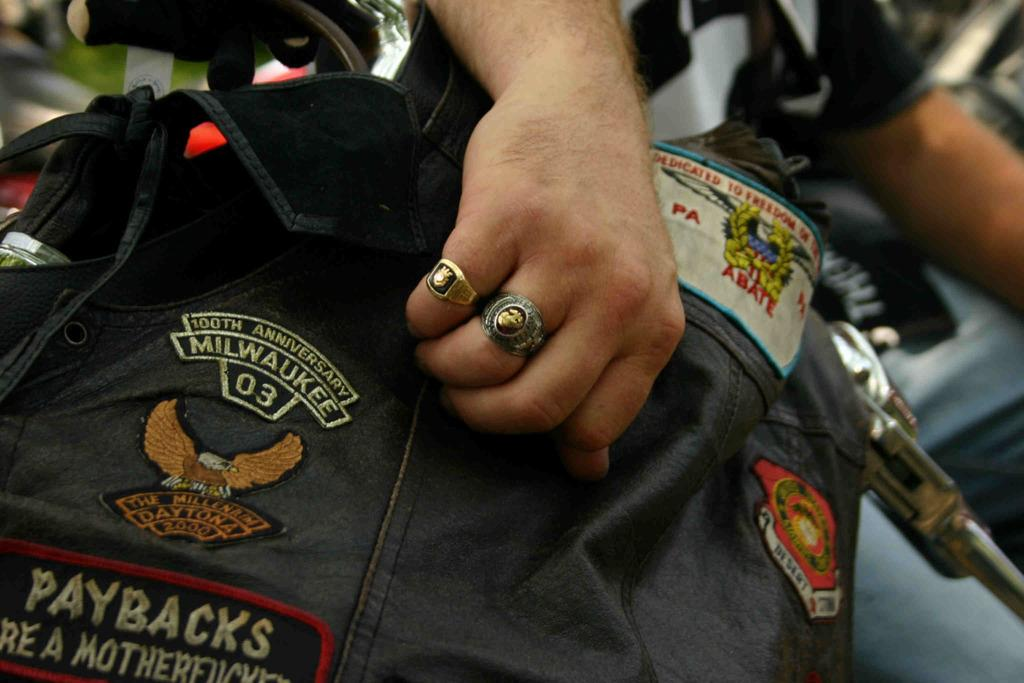What can be seen in the image? There is a person and an object in the image. Can you describe the person in the image? Unfortunately, the provided facts do not give any details about the person's appearance or clothing. What is the object in the image? The facts only mention that there is an object in the image, but do not specify what it is. What design can be seen on the person's clothing in the image? There is no information about the person's clothing or any design on it. --- 